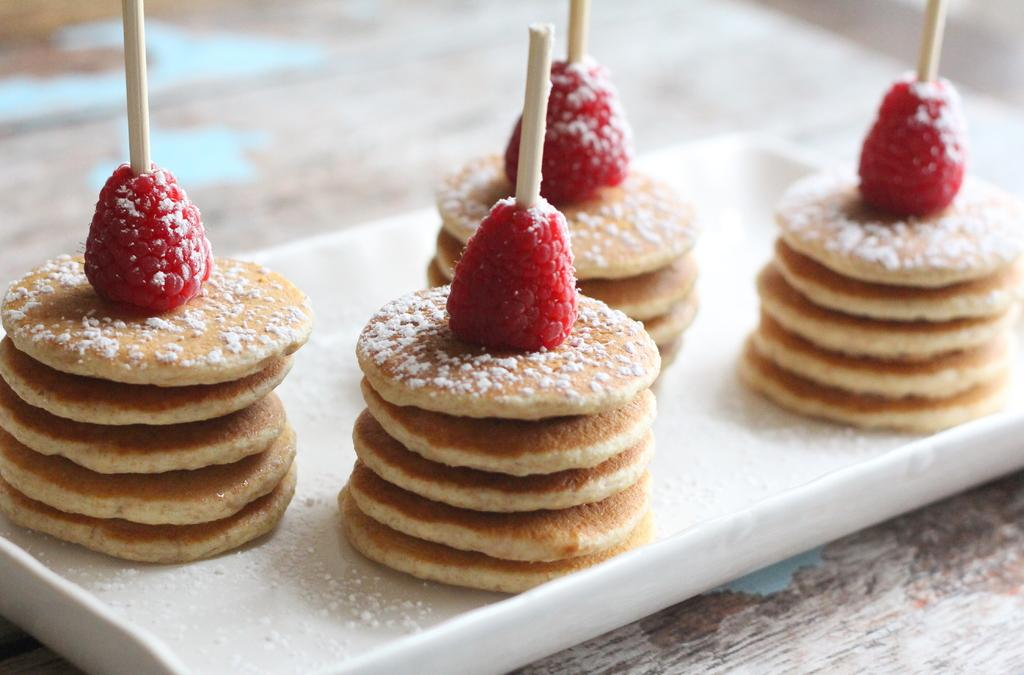What type of objects can be seen in the image? There are food items in the image. How are the food items arranged or presented? The food items are on a white plate. What type of ball is visible in the image? There is no ball present in the image. How many bits of food are on the plate? The term "bit" is not relevant to the image, as it refers to a small piece or portion, and the image only provides information about the food items being on a white plate. 